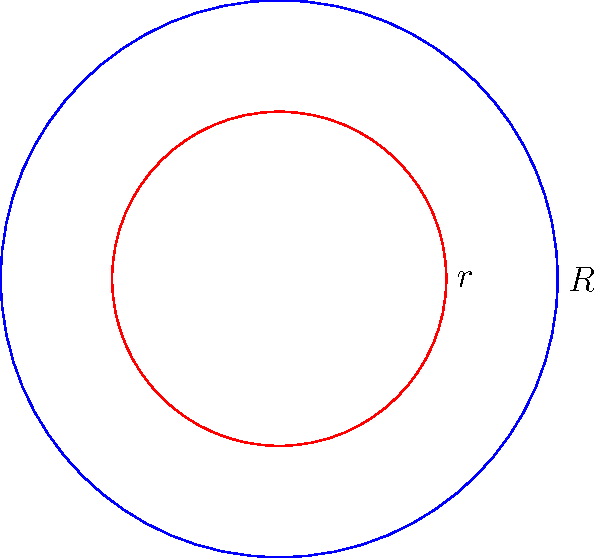Two concentric circles are shown in the diagram. The larger circle has a radius $R$ of 5 units, and the smaller circle has a radius $r$ of 3 units. Calculate the area of the region between these two circles. To find the area between two concentric circles, we need to:

1. Calculate the area of the larger circle:
   $A_1 = \pi R^2 = \pi (5)^2 = 25\pi$ square units

2. Calculate the area of the smaller circle:
   $A_2 = \pi r^2 = \pi (3)^2 = 9\pi$ square units

3. Subtract the area of the smaller circle from the area of the larger circle:
   $A_{region} = A_1 - A_2 = 25\pi - 9\pi = 16\pi$ square units

Therefore, the area of the region between the two concentric circles is $16\pi$ square units.
Answer: $16\pi$ square units 